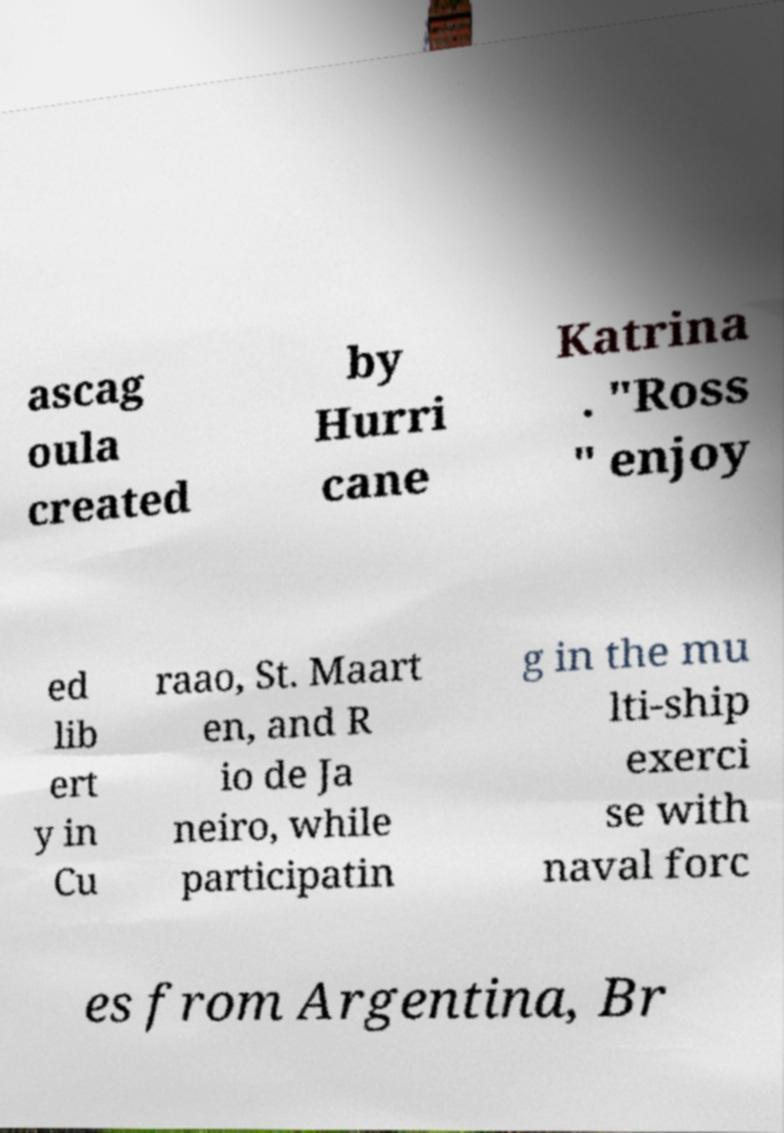I need the written content from this picture converted into text. Can you do that? ascag oula created by Hurri cane Katrina . "Ross " enjoy ed lib ert y in Cu raao, St. Maart en, and R io de Ja neiro, while participatin g in the mu lti-ship exerci se with naval forc es from Argentina, Br 